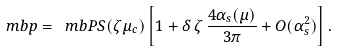<formula> <loc_0><loc_0><loc_500><loc_500>\ m b p = \ m b P S ( \zeta \mu _ { c } ) \left [ 1 + \delta \, \zeta \, \frac { 4 \alpha _ { s } ( \mu ) } { 3 \pi } + O ( \alpha _ { s } ^ { 2 } ) \right ] .</formula> 